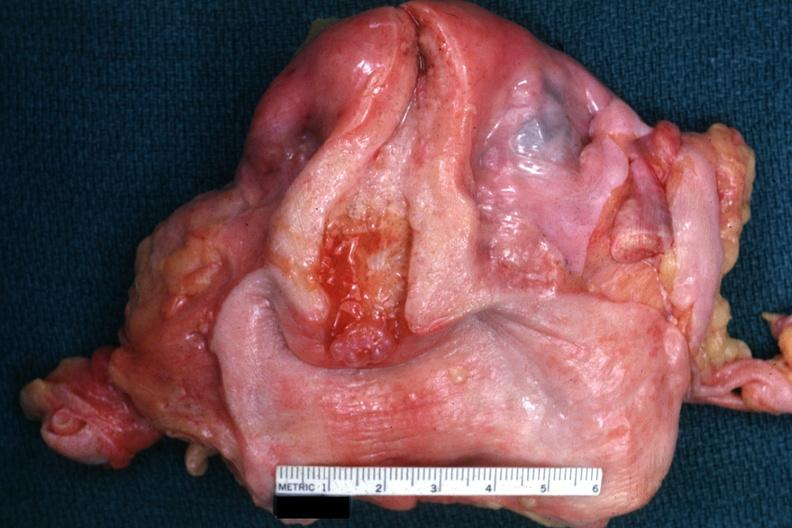s lymphangiomatosis generalized present?
Answer the question using a single word or phrase. No 